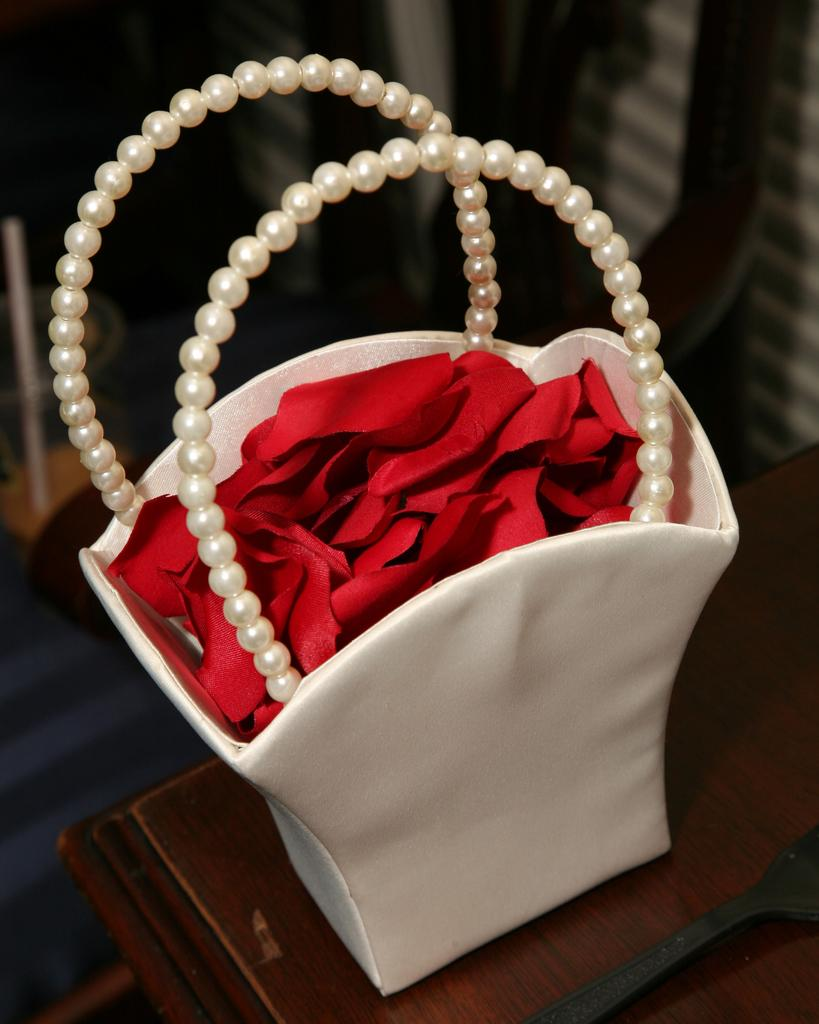What type of furniture is present in the image? There is a table in the image. What color is the table? The table is brown. What is placed on the table? There is a white bag on the table. What is inside the white bag? The bag contains red clothes. What type of wood is used to make the table in the image? The facts provided do not mention the type of wood used to make the table, so it cannot be determined from the image. 